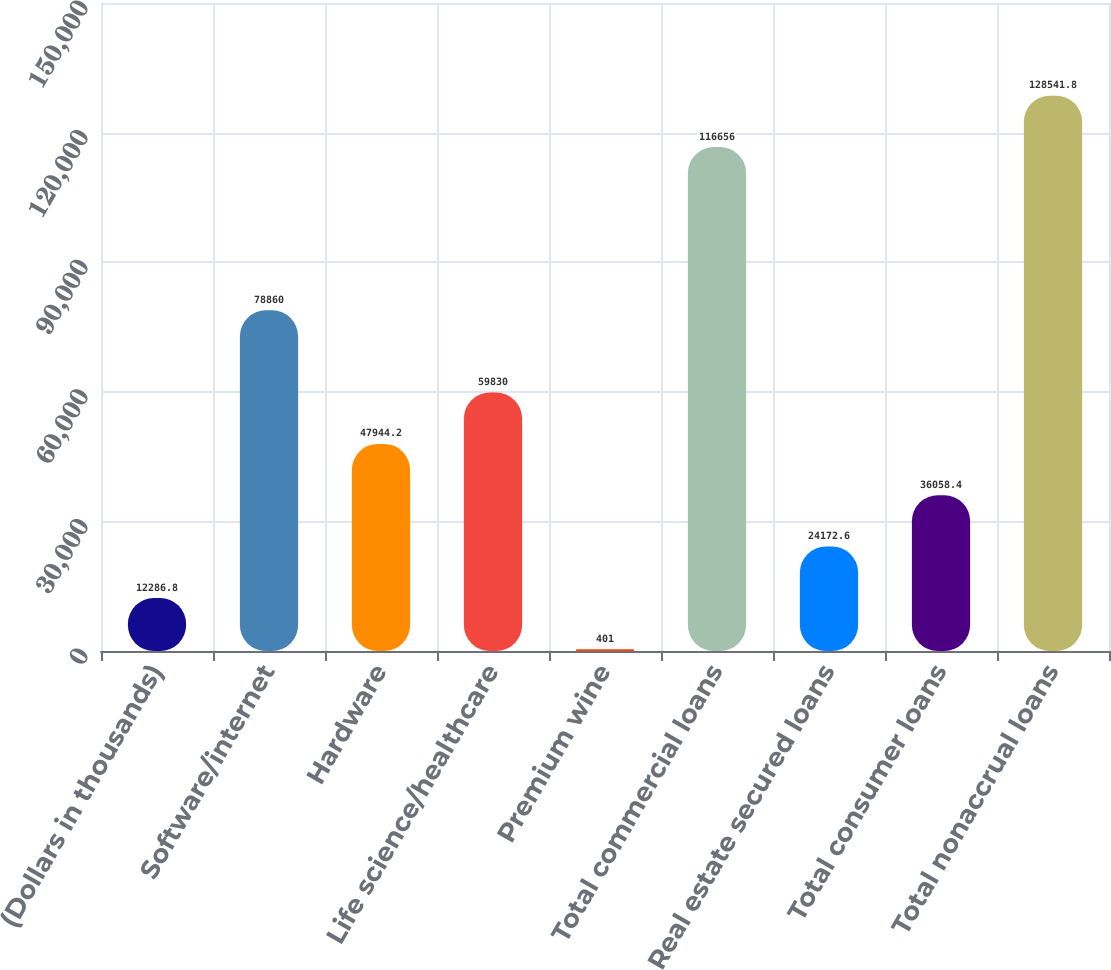<chart> <loc_0><loc_0><loc_500><loc_500><bar_chart><fcel>(Dollars in thousands)<fcel>Software/internet<fcel>Hardware<fcel>Life science/healthcare<fcel>Premium wine<fcel>Total commercial loans<fcel>Real estate secured loans<fcel>Total consumer loans<fcel>Total nonaccrual loans<nl><fcel>12286.8<fcel>78860<fcel>47944.2<fcel>59830<fcel>401<fcel>116656<fcel>24172.6<fcel>36058.4<fcel>128542<nl></chart> 